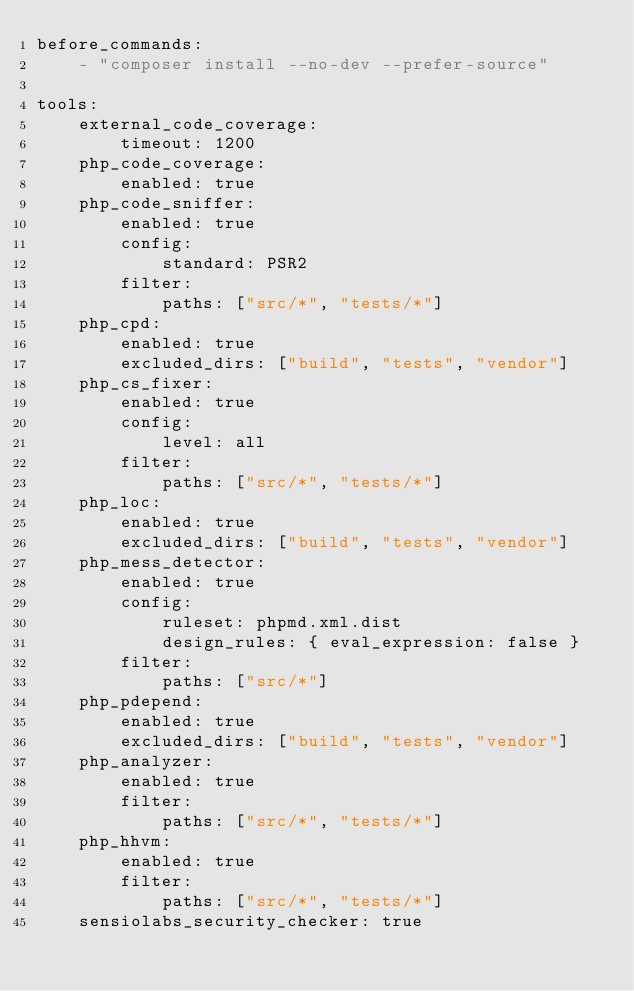<code> <loc_0><loc_0><loc_500><loc_500><_YAML_>before_commands:
    - "composer install --no-dev --prefer-source"

tools:
    external_code_coverage:
        timeout: 1200
    php_code_coverage:
        enabled: true
    php_code_sniffer:
        enabled: true
        config:
            standard: PSR2
        filter:
            paths: ["src/*", "tests/*"]
    php_cpd:
        enabled: true
        excluded_dirs: ["build", "tests", "vendor"]
    php_cs_fixer:
        enabled: true
        config:
            level: all
        filter:
            paths: ["src/*", "tests/*"]
    php_loc:
        enabled: true
        excluded_dirs: ["build", "tests", "vendor"]
    php_mess_detector:
        enabled: true
        config:
            ruleset: phpmd.xml.dist
            design_rules: { eval_expression: false }
        filter:
            paths: ["src/*"]
    php_pdepend:
        enabled: true
        excluded_dirs: ["build", "tests", "vendor"]
    php_analyzer:
        enabled: true
        filter:
            paths: ["src/*", "tests/*"]
    php_hhvm:
        enabled: true
        filter:
            paths: ["src/*", "tests/*"]
    sensiolabs_security_checker: true
</code> 